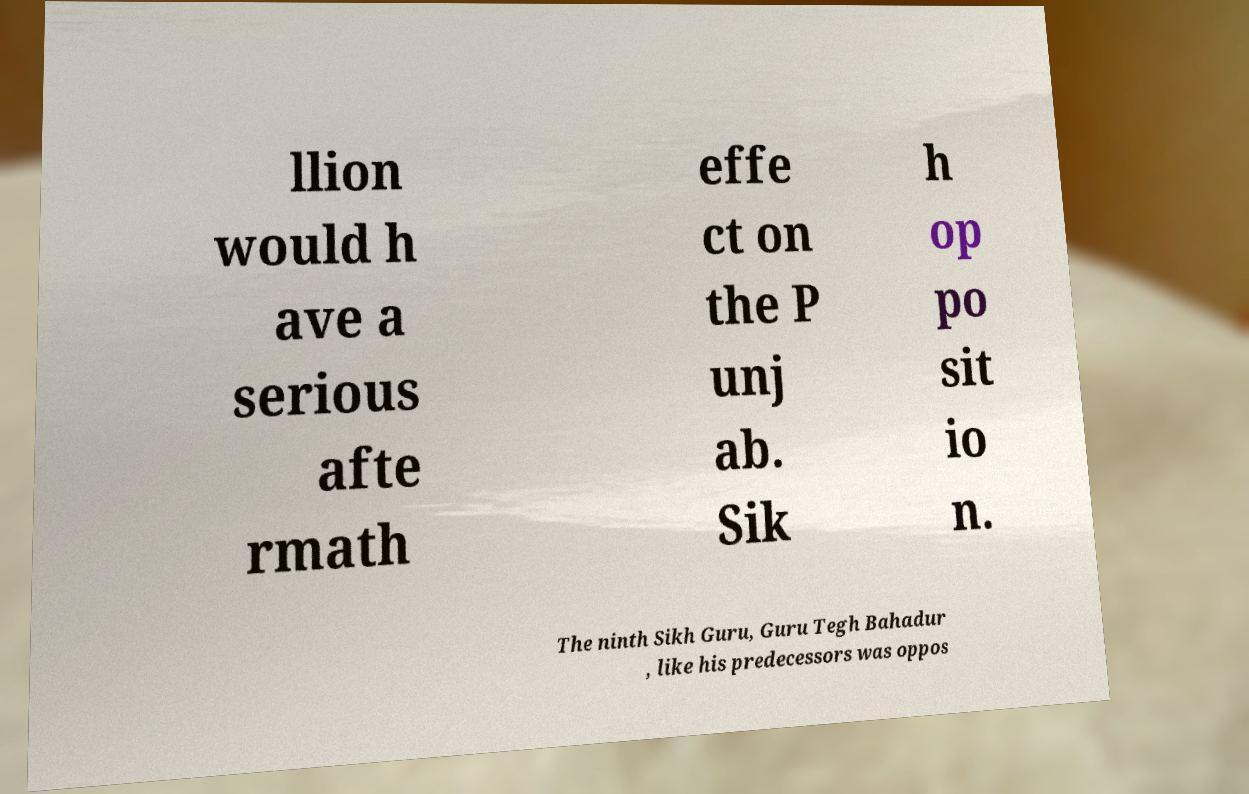What messages or text are displayed in this image? I need them in a readable, typed format. llion would h ave a serious afte rmath effe ct on the P unj ab. Sik h op po sit io n. The ninth Sikh Guru, Guru Tegh Bahadur , like his predecessors was oppos 